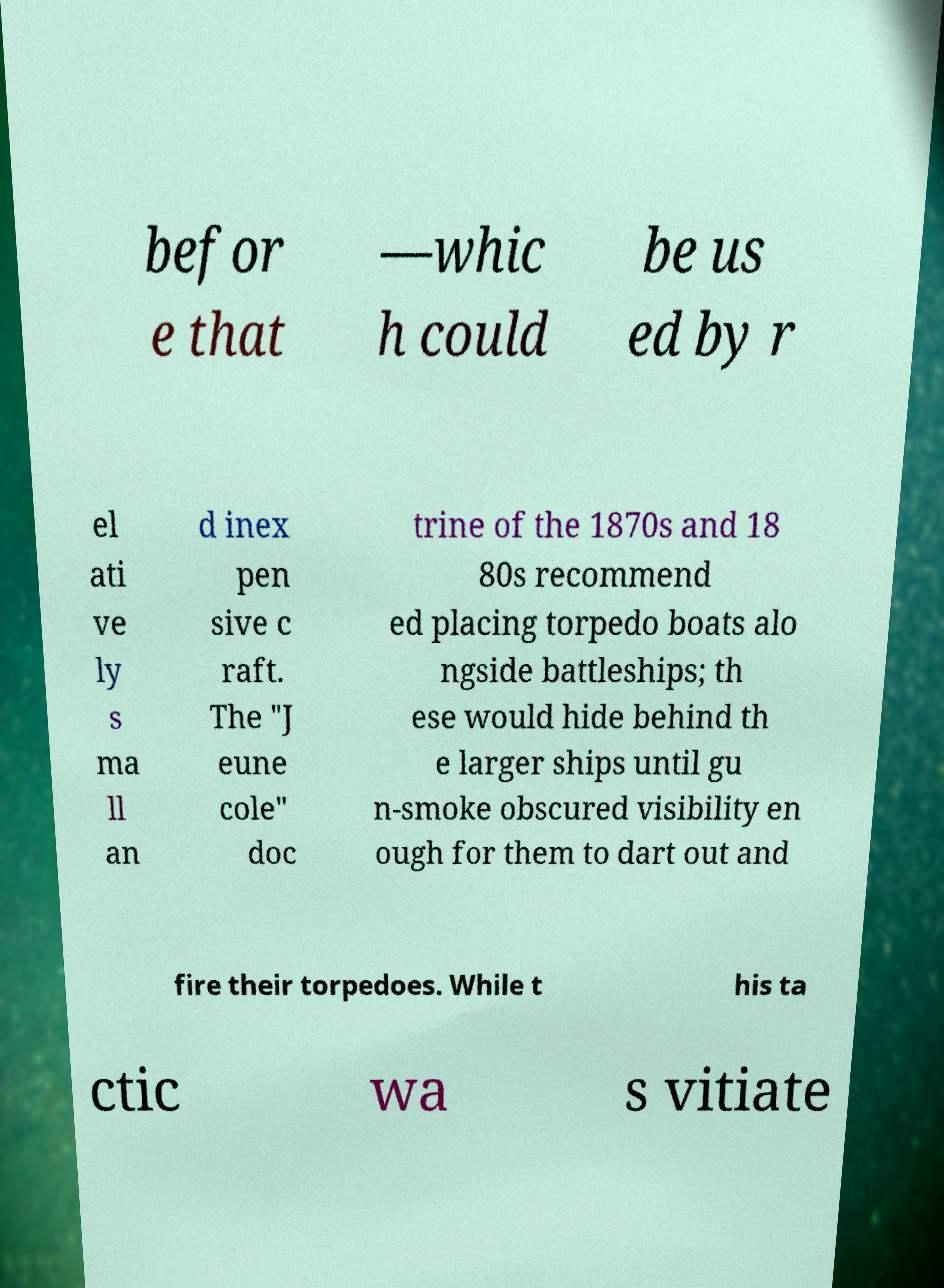Please read and relay the text visible in this image. What does it say? befor e that —whic h could be us ed by r el ati ve ly s ma ll an d inex pen sive c raft. The "J eune cole" doc trine of the 1870s and 18 80s recommend ed placing torpedo boats alo ngside battleships; th ese would hide behind th e larger ships until gu n-smoke obscured visibility en ough for them to dart out and fire their torpedoes. While t his ta ctic wa s vitiate 